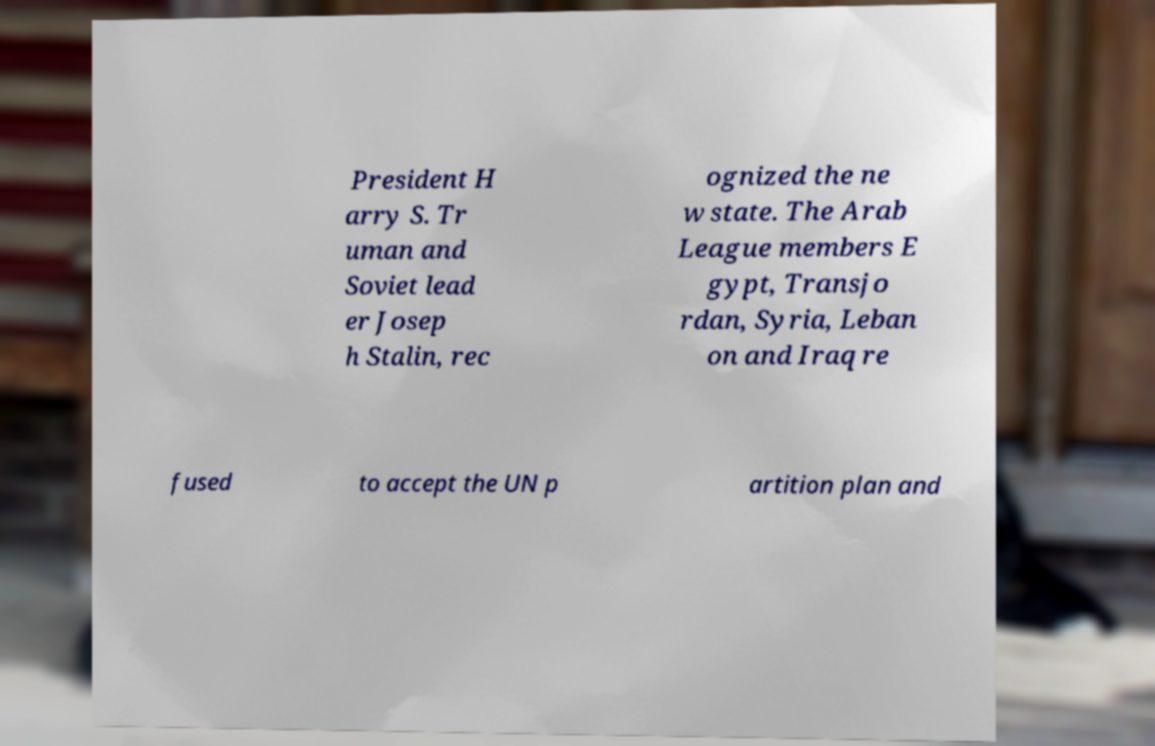I need the written content from this picture converted into text. Can you do that? President H arry S. Tr uman and Soviet lead er Josep h Stalin, rec ognized the ne w state. The Arab League members E gypt, Transjo rdan, Syria, Leban on and Iraq re fused to accept the UN p artition plan and 